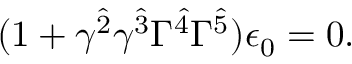Convert formula to latex. <formula><loc_0><loc_0><loc_500><loc_500>( 1 + \gamma ^ { \hat { 2 } } \gamma ^ { \hat { 3 } } \Gamma ^ { \hat { 4 } } \Gamma ^ { \hat { 5 } } ) \epsilon _ { 0 } = 0 .</formula> 